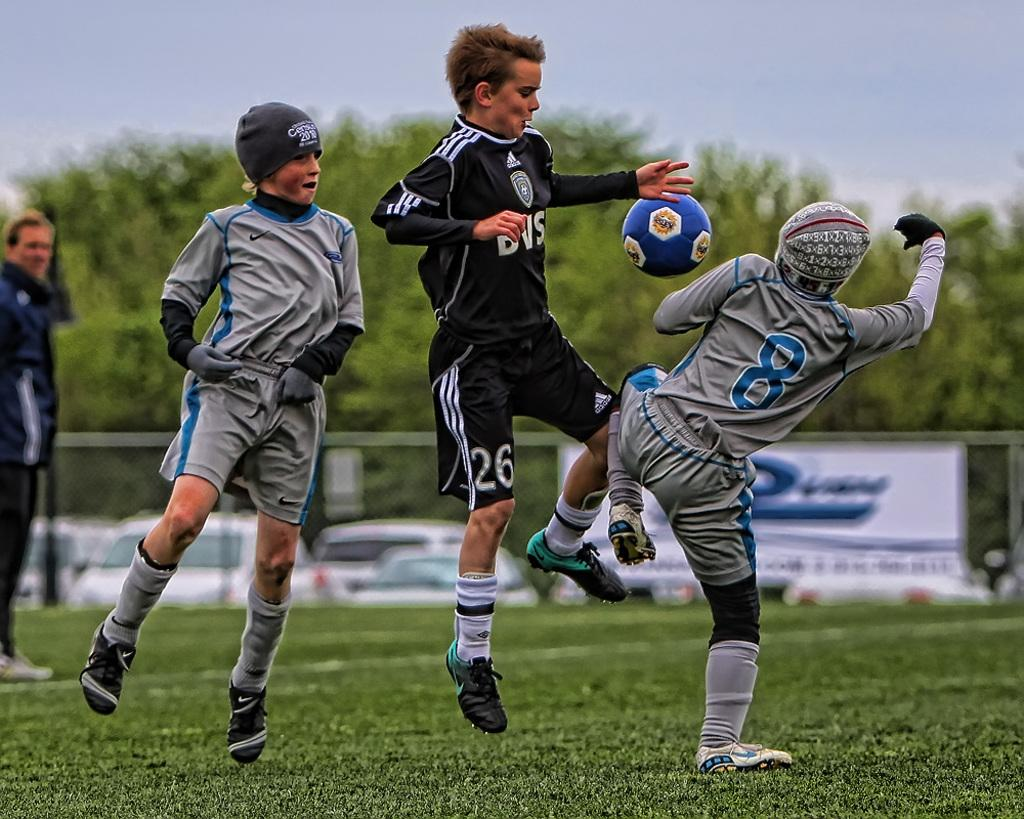What activity are the boys in the image engaged in? The boys are playing football in the image. What is the surface they are playing on? The floor is covered with grass. What can be seen in the background of the image? There are trees in the background of the image. How would you describe the sky in the image? The sky is full of clouds. Where is the hen sitting in the image? There is no hen present in the image. What part of the boys' bodies are they using for comfort while playing football? The question assumes that the boys are seeking comfort while playing football, which is not mentioned in the facts provided. 